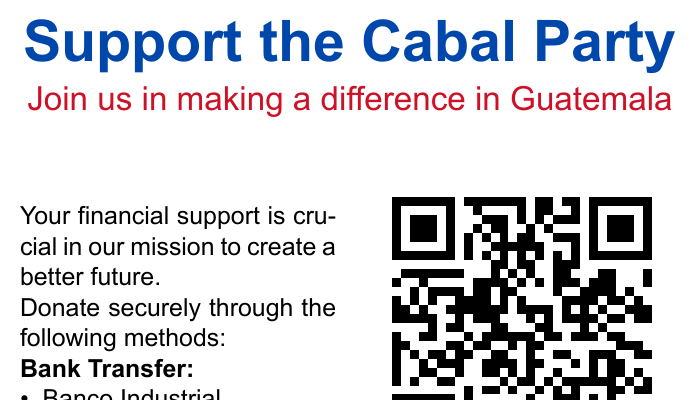What is the name of the bank for donations? The bank specified for donations is Banco Industrial.
Answer: Banco Industrial What is the bank account number for the Cabal Party? The document states that the account number for the Cabal Party is 1234567890.
Answer: 1234567890 What mobile payment service can be used for donations? The mobile payment service mentioned is TIGO Money.
Answer: TIGO Money What is the SWIFT code for the bank transfer? The SWIFT code for Banco Industrial is INDLGTGC.
Answer: INDLGTGC What is the contact email for donation inquiries? The document provides the contact email as support@cabalparty.gt.
Answer: support@cabalparty.gt Where can you scan the QR code for donations? The QR code can be scanned using a mobile device for quick donations.
Answer: mobile device What color is the background of the back of the card? The background color of the back card is light blue with a tint of cabal blue.
Answer: cabal blue!10 How can you donate quickly and securely? Donations can be made quickly and securely by scanning the QR code.
Answer: scanning the QR code 